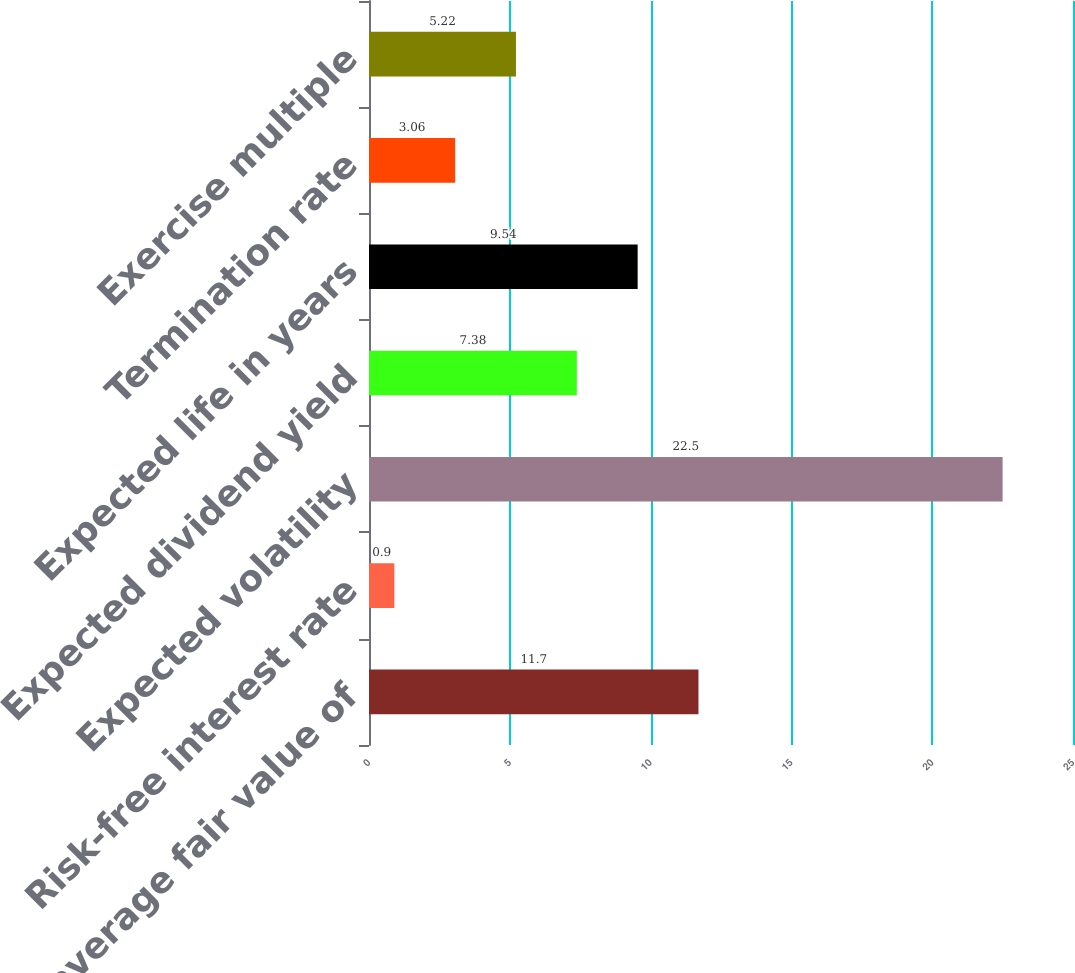<chart> <loc_0><loc_0><loc_500><loc_500><bar_chart><fcel>Weighted average fair value of<fcel>Risk-free interest rate<fcel>Expected volatility<fcel>Expected dividend yield<fcel>Expected life in years<fcel>Termination rate<fcel>Exercise multiple<nl><fcel>11.7<fcel>0.9<fcel>22.5<fcel>7.38<fcel>9.54<fcel>3.06<fcel>5.22<nl></chart> 